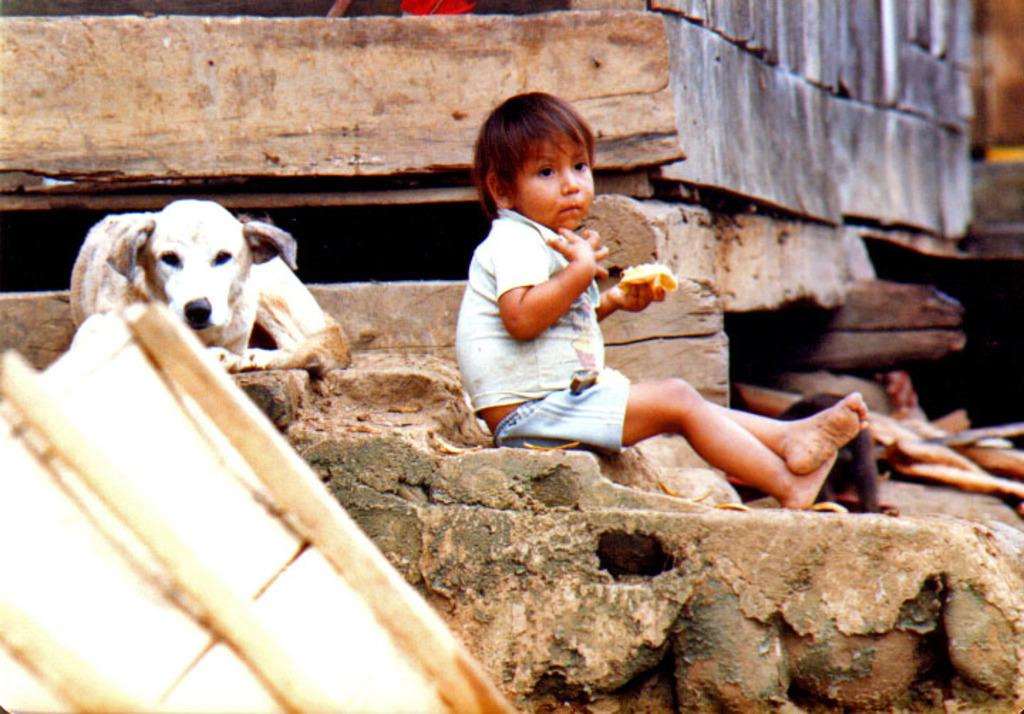What is the main subject of the image? The main subjects of the image are a kid and a dog. Where are the kid and the dog located in the image? Both the kid and the dog are on a rock surface. What is visible behind the kid? There is a wall behind the kid. What can be seen at the bottom of the image? There is an object at the bottom of the image. What type of eggnog is being served to the dog in the image? There is no eggnog present in the image; it features a kid and a dog on a rock surface with a wall behind the kid and an object at the bottom of the image. What is the significance of the dog's birth in the image? There is no mention of the dog's birth or any related significance in the image. 